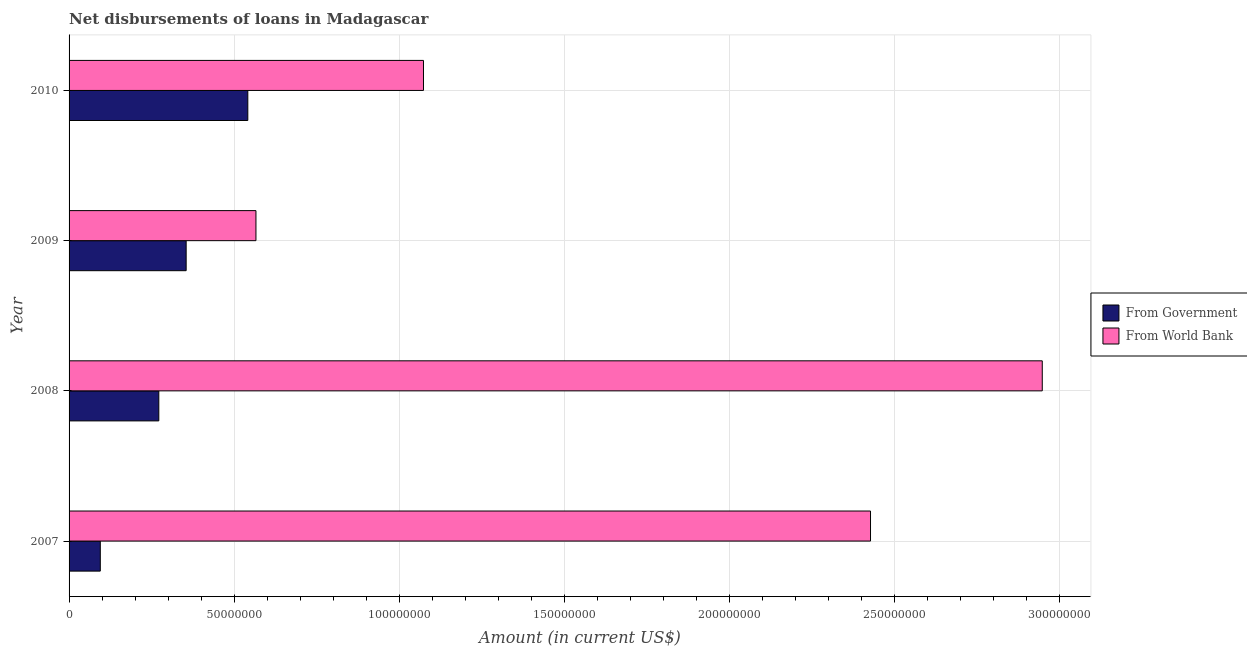How many different coloured bars are there?
Make the answer very short. 2. Are the number of bars on each tick of the Y-axis equal?
Your answer should be compact. Yes. How many bars are there on the 3rd tick from the bottom?
Give a very brief answer. 2. What is the label of the 4th group of bars from the top?
Provide a succinct answer. 2007. In how many cases, is the number of bars for a given year not equal to the number of legend labels?
Offer a terse response. 0. What is the net disbursements of loan from world bank in 2007?
Ensure brevity in your answer.  2.43e+08. Across all years, what is the maximum net disbursements of loan from government?
Offer a terse response. 5.42e+07. Across all years, what is the minimum net disbursements of loan from government?
Make the answer very short. 9.46e+06. In which year was the net disbursements of loan from government maximum?
Keep it short and to the point. 2010. In which year was the net disbursements of loan from government minimum?
Provide a succinct answer. 2007. What is the total net disbursements of loan from world bank in the graph?
Keep it short and to the point. 7.02e+08. What is the difference between the net disbursements of loan from government in 2008 and that in 2009?
Keep it short and to the point. -8.28e+06. What is the difference between the net disbursements of loan from government in 2008 and the net disbursements of loan from world bank in 2010?
Provide a short and direct response. -8.02e+07. What is the average net disbursements of loan from government per year?
Your response must be concise. 3.16e+07. In the year 2007, what is the difference between the net disbursements of loan from world bank and net disbursements of loan from government?
Provide a short and direct response. 2.33e+08. In how many years, is the net disbursements of loan from world bank greater than 100000000 US$?
Ensure brevity in your answer.  3. What is the ratio of the net disbursements of loan from world bank in 2009 to that in 2010?
Give a very brief answer. 0.53. What is the difference between the highest and the second highest net disbursements of loan from world bank?
Offer a terse response. 5.20e+07. What is the difference between the highest and the lowest net disbursements of loan from world bank?
Keep it short and to the point. 2.38e+08. In how many years, is the net disbursements of loan from world bank greater than the average net disbursements of loan from world bank taken over all years?
Offer a very short reply. 2. What does the 2nd bar from the top in 2009 represents?
Keep it short and to the point. From Government. What does the 2nd bar from the bottom in 2009 represents?
Your answer should be very brief. From World Bank. Are all the bars in the graph horizontal?
Give a very brief answer. Yes. How many years are there in the graph?
Your answer should be very brief. 4. Are the values on the major ticks of X-axis written in scientific E-notation?
Keep it short and to the point. No. Does the graph contain grids?
Provide a short and direct response. Yes. Where does the legend appear in the graph?
Keep it short and to the point. Center right. How many legend labels are there?
Offer a terse response. 2. What is the title of the graph?
Your answer should be compact. Net disbursements of loans in Madagascar. What is the label or title of the Y-axis?
Offer a terse response. Year. What is the Amount (in current US$) in From Government in 2007?
Ensure brevity in your answer.  9.46e+06. What is the Amount (in current US$) in From World Bank in 2007?
Provide a succinct answer. 2.43e+08. What is the Amount (in current US$) of From Government in 2008?
Give a very brief answer. 2.72e+07. What is the Amount (in current US$) in From World Bank in 2008?
Give a very brief answer. 2.95e+08. What is the Amount (in current US$) in From Government in 2009?
Your response must be concise. 3.55e+07. What is the Amount (in current US$) in From World Bank in 2009?
Provide a short and direct response. 5.66e+07. What is the Amount (in current US$) in From Government in 2010?
Your answer should be very brief. 5.42e+07. What is the Amount (in current US$) of From World Bank in 2010?
Keep it short and to the point. 1.07e+08. Across all years, what is the maximum Amount (in current US$) in From Government?
Your answer should be very brief. 5.42e+07. Across all years, what is the maximum Amount (in current US$) in From World Bank?
Give a very brief answer. 2.95e+08. Across all years, what is the minimum Amount (in current US$) of From Government?
Keep it short and to the point. 9.46e+06. Across all years, what is the minimum Amount (in current US$) in From World Bank?
Your answer should be compact. 5.66e+07. What is the total Amount (in current US$) of From Government in the graph?
Ensure brevity in your answer.  1.26e+08. What is the total Amount (in current US$) of From World Bank in the graph?
Keep it short and to the point. 7.02e+08. What is the difference between the Amount (in current US$) of From Government in 2007 and that in 2008?
Provide a short and direct response. -1.77e+07. What is the difference between the Amount (in current US$) in From World Bank in 2007 and that in 2008?
Ensure brevity in your answer.  -5.20e+07. What is the difference between the Amount (in current US$) of From Government in 2007 and that in 2009?
Ensure brevity in your answer.  -2.60e+07. What is the difference between the Amount (in current US$) in From World Bank in 2007 and that in 2009?
Your answer should be compact. 1.86e+08. What is the difference between the Amount (in current US$) of From Government in 2007 and that in 2010?
Make the answer very short. -4.47e+07. What is the difference between the Amount (in current US$) of From World Bank in 2007 and that in 2010?
Make the answer very short. 1.35e+08. What is the difference between the Amount (in current US$) in From Government in 2008 and that in 2009?
Provide a short and direct response. -8.28e+06. What is the difference between the Amount (in current US$) in From World Bank in 2008 and that in 2009?
Your answer should be very brief. 2.38e+08. What is the difference between the Amount (in current US$) in From Government in 2008 and that in 2010?
Ensure brevity in your answer.  -2.70e+07. What is the difference between the Amount (in current US$) of From World Bank in 2008 and that in 2010?
Your response must be concise. 1.87e+08. What is the difference between the Amount (in current US$) in From Government in 2009 and that in 2010?
Provide a succinct answer. -1.87e+07. What is the difference between the Amount (in current US$) in From World Bank in 2009 and that in 2010?
Make the answer very short. -5.08e+07. What is the difference between the Amount (in current US$) in From Government in 2007 and the Amount (in current US$) in From World Bank in 2008?
Keep it short and to the point. -2.85e+08. What is the difference between the Amount (in current US$) in From Government in 2007 and the Amount (in current US$) in From World Bank in 2009?
Keep it short and to the point. -4.72e+07. What is the difference between the Amount (in current US$) of From Government in 2007 and the Amount (in current US$) of From World Bank in 2010?
Offer a very short reply. -9.79e+07. What is the difference between the Amount (in current US$) in From Government in 2008 and the Amount (in current US$) in From World Bank in 2009?
Offer a very short reply. -2.94e+07. What is the difference between the Amount (in current US$) in From Government in 2008 and the Amount (in current US$) in From World Bank in 2010?
Provide a succinct answer. -8.02e+07. What is the difference between the Amount (in current US$) in From Government in 2009 and the Amount (in current US$) in From World Bank in 2010?
Make the answer very short. -7.19e+07. What is the average Amount (in current US$) of From Government per year?
Give a very brief answer. 3.16e+07. What is the average Amount (in current US$) in From World Bank per year?
Offer a very short reply. 1.75e+08. In the year 2007, what is the difference between the Amount (in current US$) of From Government and Amount (in current US$) of From World Bank?
Give a very brief answer. -2.33e+08. In the year 2008, what is the difference between the Amount (in current US$) of From Government and Amount (in current US$) of From World Bank?
Offer a terse response. -2.68e+08. In the year 2009, what is the difference between the Amount (in current US$) in From Government and Amount (in current US$) in From World Bank?
Offer a very short reply. -2.11e+07. In the year 2010, what is the difference between the Amount (in current US$) in From Government and Amount (in current US$) in From World Bank?
Offer a terse response. -5.32e+07. What is the ratio of the Amount (in current US$) of From Government in 2007 to that in 2008?
Provide a short and direct response. 0.35. What is the ratio of the Amount (in current US$) in From World Bank in 2007 to that in 2008?
Your answer should be very brief. 0.82. What is the ratio of the Amount (in current US$) in From Government in 2007 to that in 2009?
Your response must be concise. 0.27. What is the ratio of the Amount (in current US$) of From World Bank in 2007 to that in 2009?
Give a very brief answer. 4.29. What is the ratio of the Amount (in current US$) of From Government in 2007 to that in 2010?
Provide a short and direct response. 0.17. What is the ratio of the Amount (in current US$) in From World Bank in 2007 to that in 2010?
Offer a terse response. 2.26. What is the ratio of the Amount (in current US$) in From Government in 2008 to that in 2009?
Provide a succinct answer. 0.77. What is the ratio of the Amount (in current US$) of From World Bank in 2008 to that in 2009?
Your answer should be very brief. 5.21. What is the ratio of the Amount (in current US$) of From Government in 2008 to that in 2010?
Make the answer very short. 0.5. What is the ratio of the Amount (in current US$) in From World Bank in 2008 to that in 2010?
Your response must be concise. 2.75. What is the ratio of the Amount (in current US$) in From Government in 2009 to that in 2010?
Your answer should be compact. 0.66. What is the ratio of the Amount (in current US$) in From World Bank in 2009 to that in 2010?
Keep it short and to the point. 0.53. What is the difference between the highest and the second highest Amount (in current US$) of From Government?
Give a very brief answer. 1.87e+07. What is the difference between the highest and the second highest Amount (in current US$) of From World Bank?
Your answer should be very brief. 5.20e+07. What is the difference between the highest and the lowest Amount (in current US$) of From Government?
Your response must be concise. 4.47e+07. What is the difference between the highest and the lowest Amount (in current US$) in From World Bank?
Keep it short and to the point. 2.38e+08. 